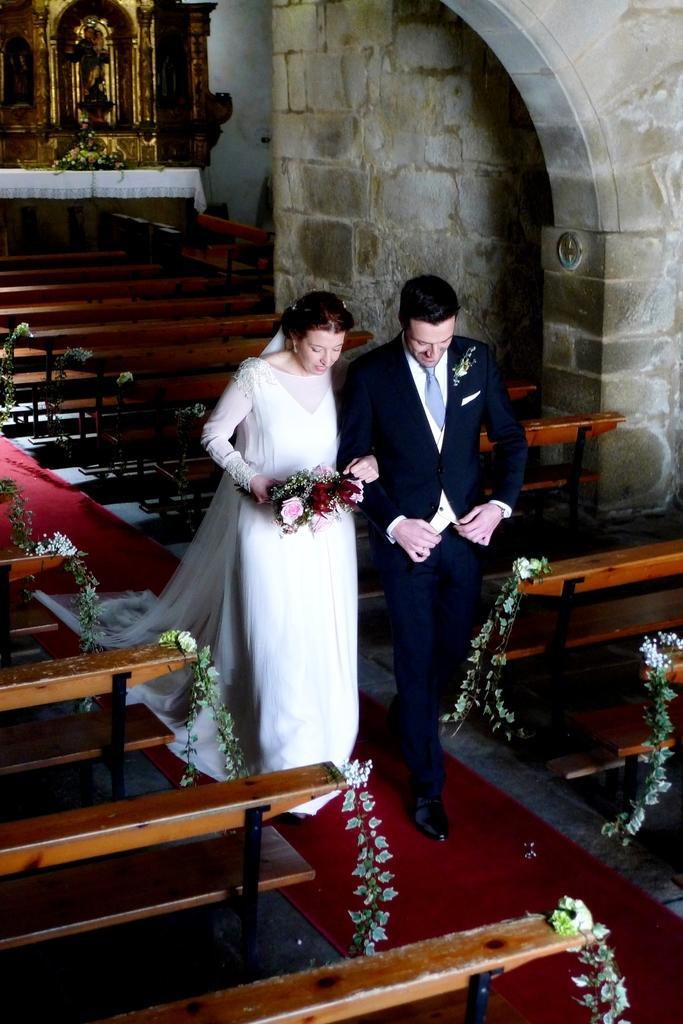Can you describe this image briefly? In this image we can see a couple walking and we can also see some benches, arch, wall and flowers. 